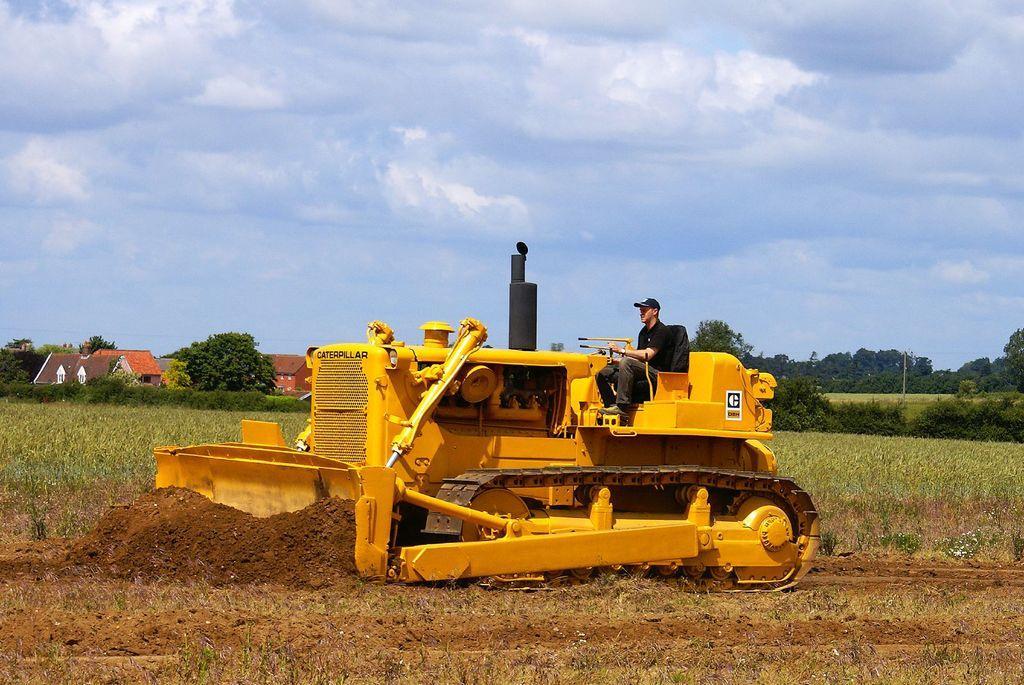Please provide a concise description of this image. In this picture I can see a vehicle in front, on which there is a man sitting and I see the soil. In the middle of this picture I see the grass, number of plants, buildings and trees. In the background I see the sky which is a bit cloudy. 